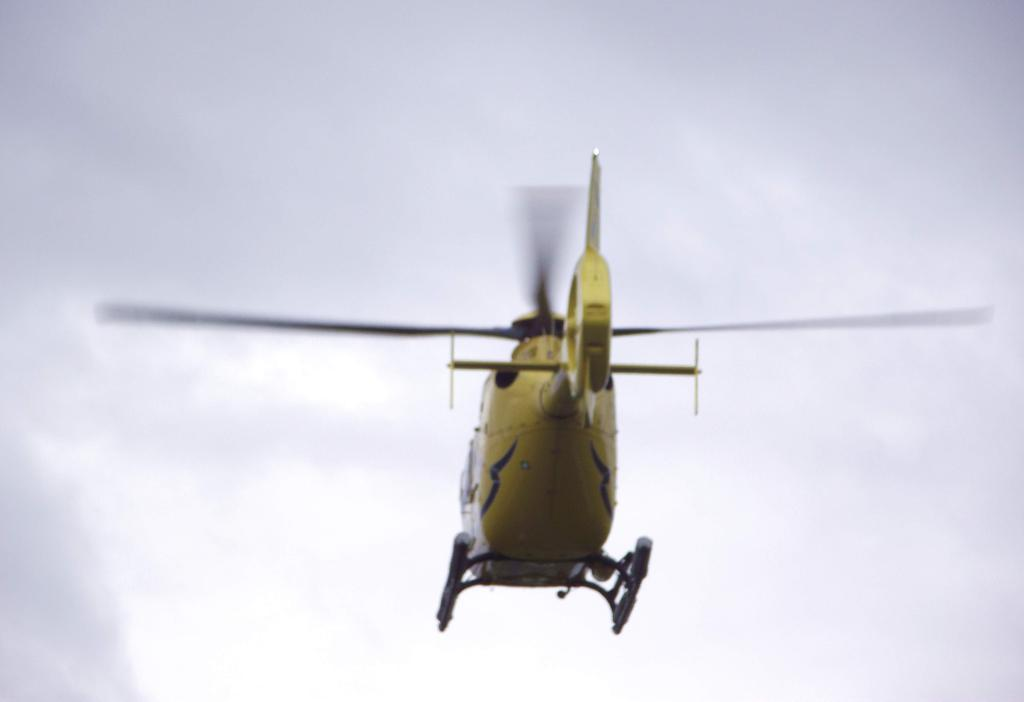What is the main subject of the image? There is a helicopter in the image. What is the helicopter doing in the image? The helicopter is flying in the sky. What can be seen in the background of the image? The sky is visible in the background of the image. What type of harmony can be heard between the helicopter and the street in the image? There is no street present in the image, and the helicopter is not making any sounds, so it is not possible to determine any harmony. 